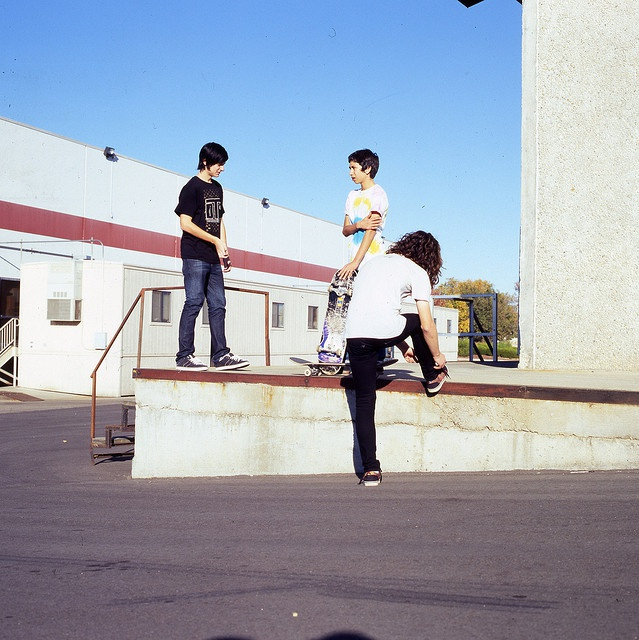Describe the objects in this image and their specific colors. I can see people in lightblue, black, white, tan, and maroon tones, people in lightblue, black, navy, purple, and white tones, people in lightblue, white, tan, and black tones, skateboard in lightblue, lightgray, darkgray, black, and gray tones, and skateboard in lightblue, ivory, black, gray, and darkgray tones in this image. 